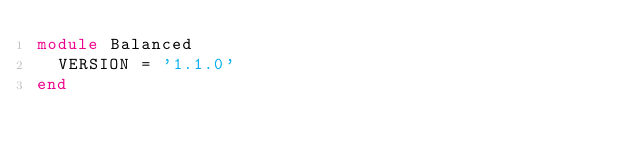<code> <loc_0><loc_0><loc_500><loc_500><_Ruby_>module Balanced
  VERSION = '1.1.0'
end
</code> 